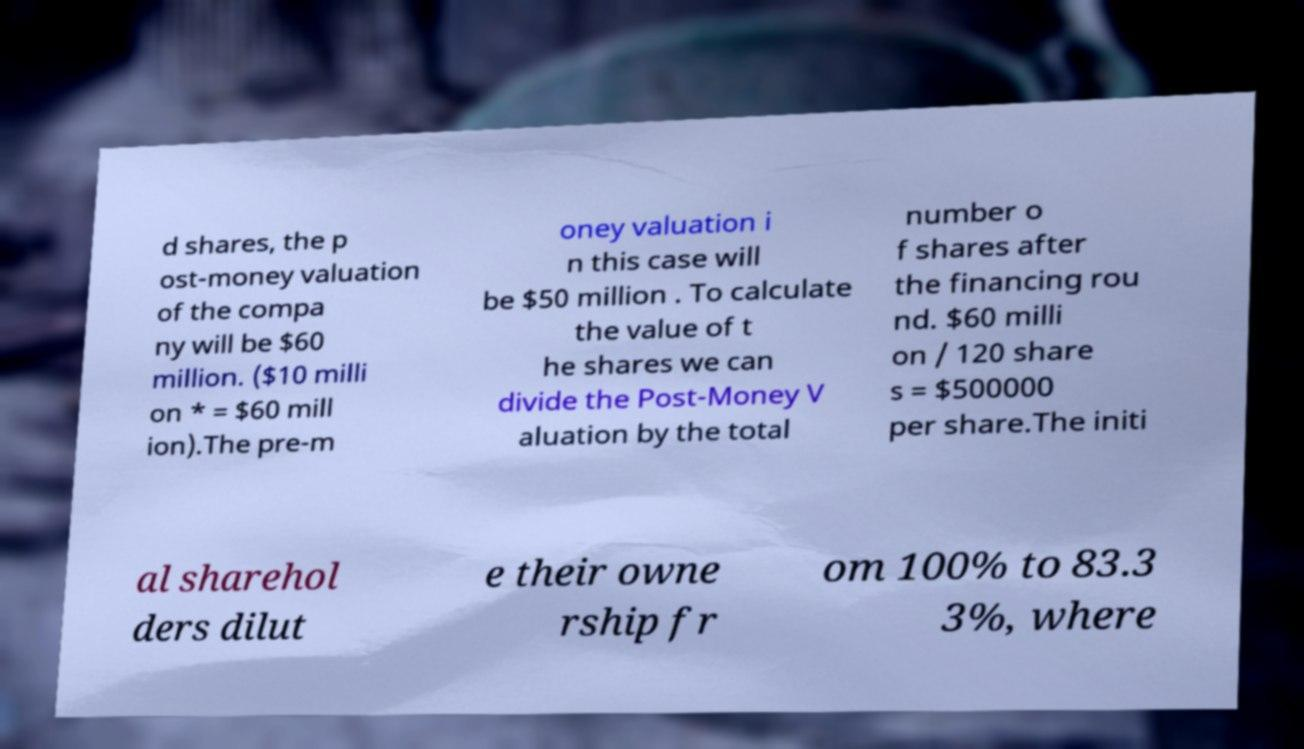What messages or text are displayed in this image? I need them in a readable, typed format. d shares, the p ost-money valuation of the compa ny will be $60 million. ($10 milli on * = $60 mill ion).The pre-m oney valuation i n this case will be $50 million . To calculate the value of t he shares we can divide the Post-Money V aluation by the total number o f shares after the financing rou nd. $60 milli on / 120 share s = $500000 per share.The initi al sharehol ders dilut e their owne rship fr om 100% to 83.3 3%, where 